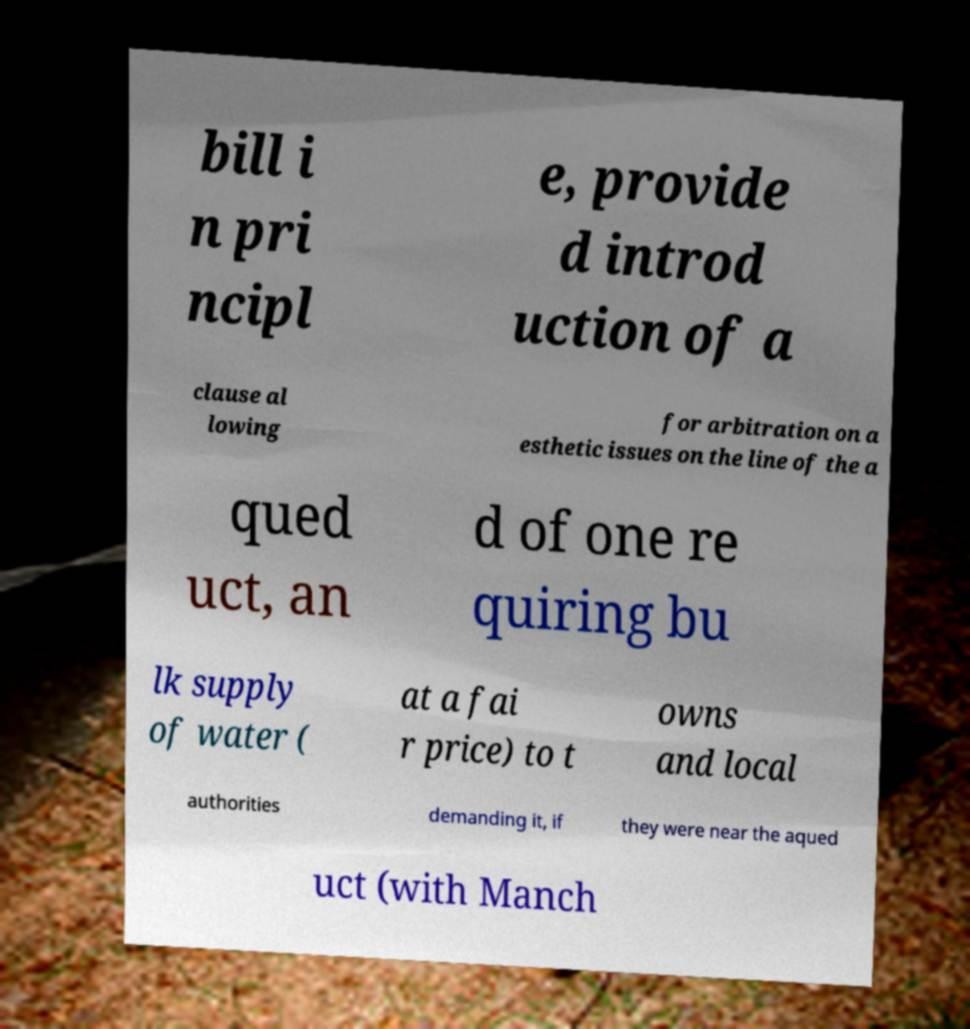Could you assist in decoding the text presented in this image and type it out clearly? bill i n pri ncipl e, provide d introd uction of a clause al lowing for arbitration on a esthetic issues on the line of the a qued uct, an d of one re quiring bu lk supply of water ( at a fai r price) to t owns and local authorities demanding it, if they were near the aqued uct (with Manch 